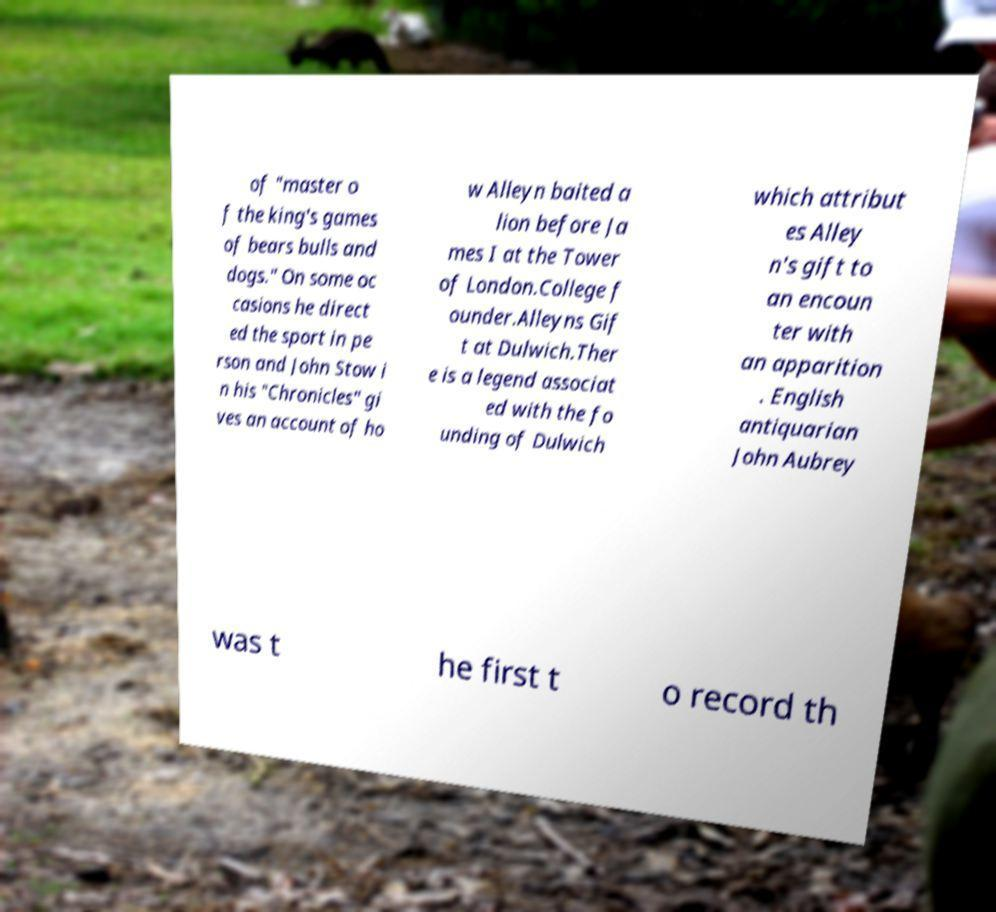Please identify and transcribe the text found in this image. of "master o f the king's games of bears bulls and dogs." On some oc casions he direct ed the sport in pe rson and John Stow i n his "Chronicles" gi ves an account of ho w Alleyn baited a lion before Ja mes I at the Tower of London.College f ounder.Alleyns Gif t at Dulwich.Ther e is a legend associat ed with the fo unding of Dulwich which attribut es Alley n's gift to an encoun ter with an apparition . English antiquarian John Aubrey was t he first t o record th 